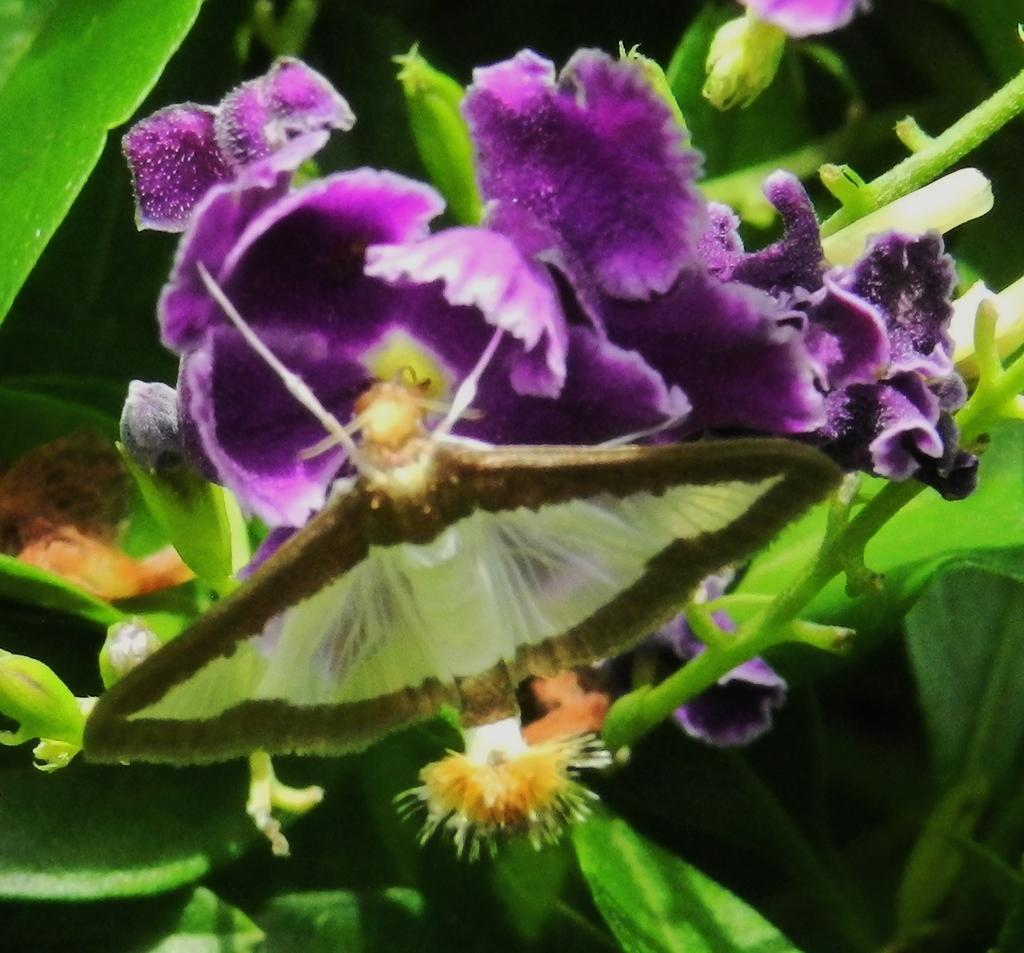Where might the picture have been taken? The picture might be taken inside the water. What types of plants can be seen in the image? There are flowers, leaves, and stems of plants in the image. What is visible in the background of the image? There is greenery in the background of the image. What type of bread can be seen on the canvas in the image? There is no bread or canvas present in the image; it features plants inside the water. 